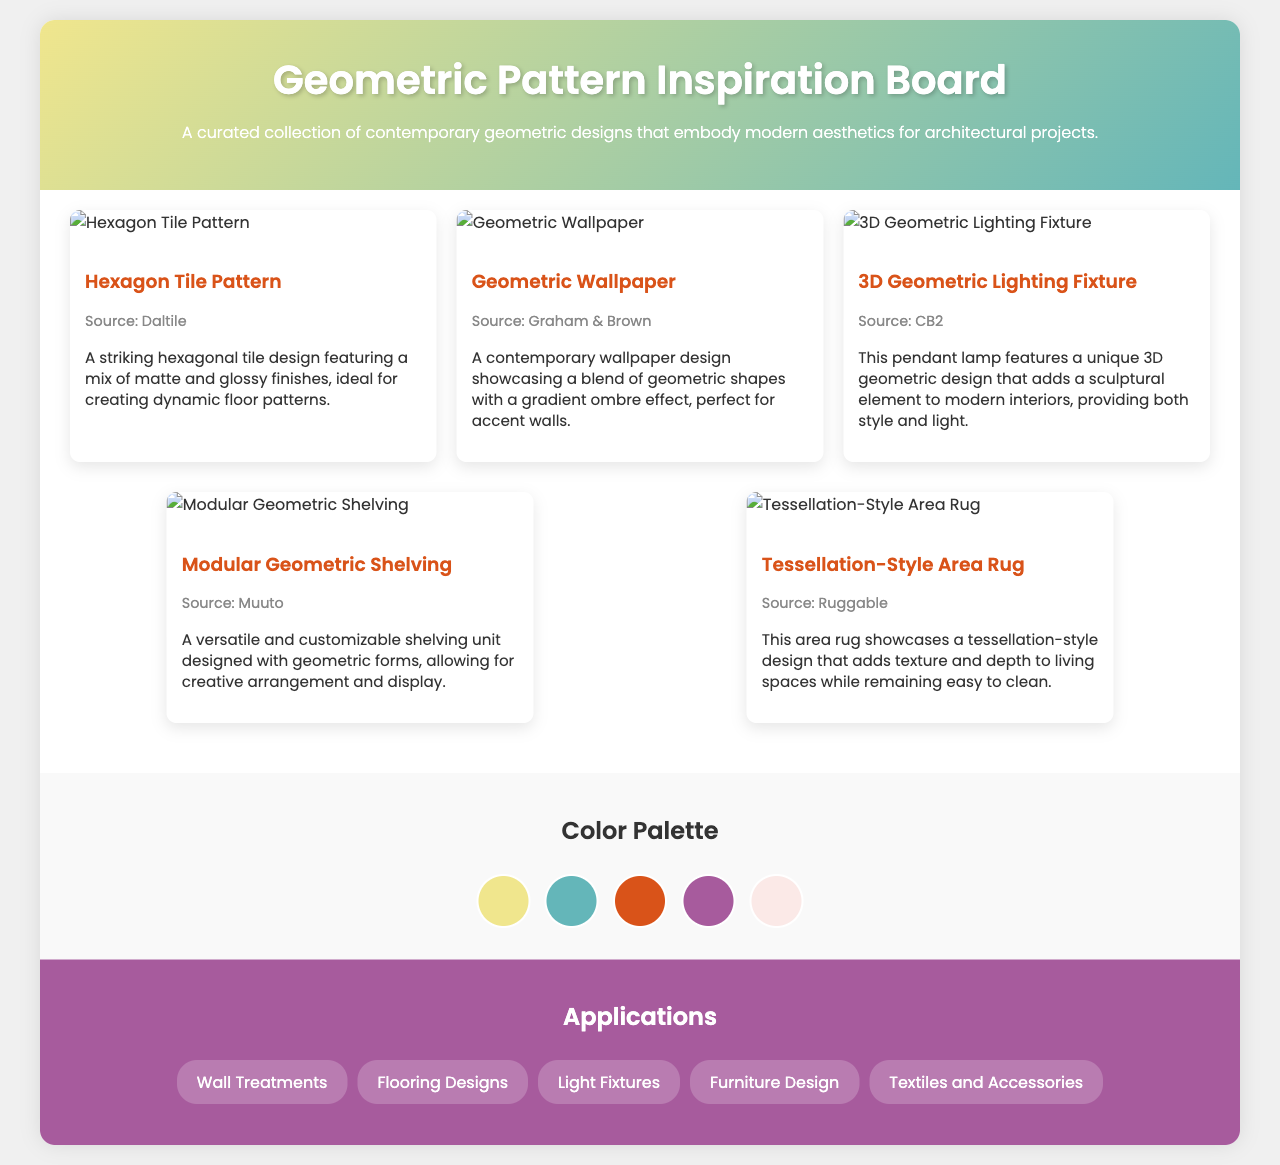What is the title of the document? The title of the document is presented prominently at the top of the page, indicating the subject matter of the content.
Answer: Geometric Pattern Inspiration Board Which pattern is sourced from Daltile? The pattern sourced from Daltile is clearly listed with its name and source throughout the document.
Answer: Hexagon Tile Pattern How many patterns are featured in the document? The document contains several visual representations of patterns, which can be counted directly in the patterns section.
Answer: Five What color is the background of the color palette section? The background color of the color palette section is specified within the document styling information.
Answer: #f9f9f9 What type of product is the "3D Geometric Lighting Fixture"? The name of the product provides its category, describing its form and intended use.
Answer: Lighting Fixture What is a unique feature of the "Modular Geometric Shelving"? The document contains specific characteristics about this shelving unit, allowing for clear identification of its versatility.
Answer: Customizable How is the "Geometric Wallpaper" described? The description for this item contains key adjectives and phrases that encapsulate its design and use.
Answer: A contemporary wallpaper design showcasing a blend of geometric shapes with a gradient ombre effect What applications are listed for the geometric patterns? The applications section details potential uses for the geometric patterns in various design contexts.
Answer: Wall Treatments, Flooring Designs, Light Fixtures, Furniture Design, Textiles and Accessories 